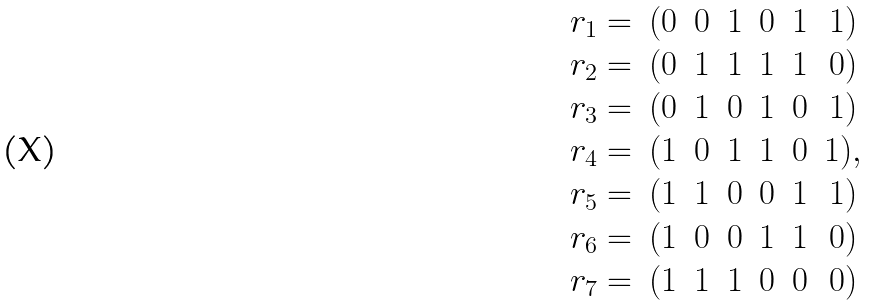<formula> <loc_0><loc_0><loc_500><loc_500>\begin{matrix} r _ { 1 } = & ( 0 & 0 & 1 & 0 & 1 & 1 ) \\ r _ { 2 } = & ( 0 & 1 & 1 & 1 & 1 & 0 ) \\ r _ { 3 } = & ( 0 & 1 & 0 & 1 & 0 & 1 ) \\ r _ { 4 } = & ( 1 & 0 & 1 & 1 & 0 & 1 ) , \\ r _ { 5 } = & ( 1 & 1 & 0 & 0 & 1 & 1 ) \\ r _ { 6 } = & ( 1 & 0 & 0 & 1 & 1 & 0 ) \\ r _ { 7 } = & ( 1 & 1 & 1 & 0 & 0 & 0 ) \\ \end{matrix}</formula> 